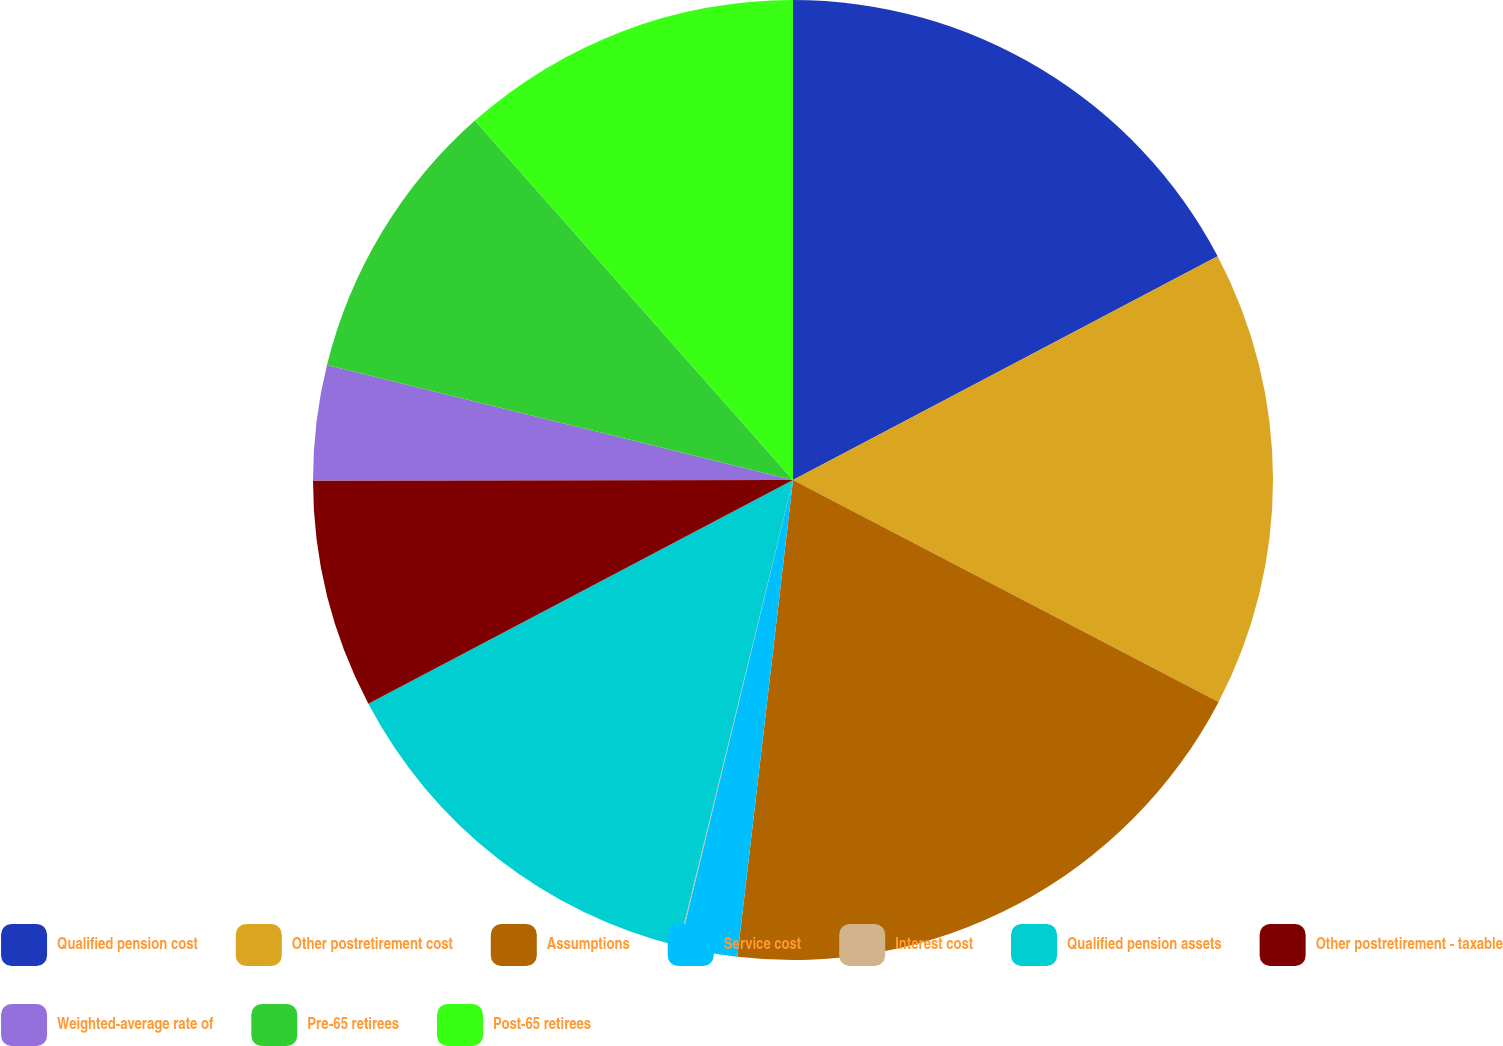Convert chart. <chart><loc_0><loc_0><loc_500><loc_500><pie_chart><fcel>Qualified pension cost<fcel>Other postretirement cost<fcel>Assumptions<fcel>Service cost<fcel>Interest cost<fcel>Qualified pension assets<fcel>Other postretirement - taxable<fcel>Weighted-average rate of<fcel>Pre-65 retirees<fcel>Post-65 retirees<nl><fcel>17.28%<fcel>15.37%<fcel>19.2%<fcel>1.95%<fcel>0.03%<fcel>13.45%<fcel>7.7%<fcel>3.87%<fcel>9.62%<fcel>11.53%<nl></chart> 